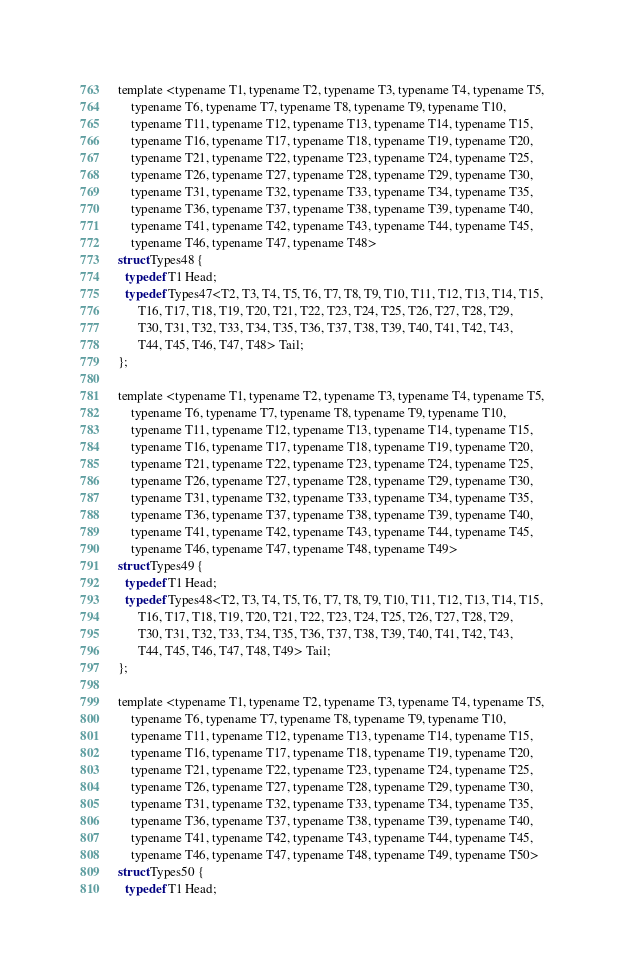<code> <loc_0><loc_0><loc_500><loc_500><_C_>template <typename T1, typename T2, typename T3, typename T4, typename T5,
    typename T6, typename T7, typename T8, typename T9, typename T10,
    typename T11, typename T12, typename T13, typename T14, typename T15,
    typename T16, typename T17, typename T18, typename T19, typename T20,
    typename T21, typename T22, typename T23, typename T24, typename T25,
    typename T26, typename T27, typename T28, typename T29, typename T30,
    typename T31, typename T32, typename T33, typename T34, typename T35,
    typename T36, typename T37, typename T38, typename T39, typename T40,
    typename T41, typename T42, typename T43, typename T44, typename T45,
    typename T46, typename T47, typename T48>
struct Types48 {
  typedef T1 Head;
  typedef Types47<T2, T3, T4, T5, T6, T7, T8, T9, T10, T11, T12, T13, T14, T15,
      T16, T17, T18, T19, T20, T21, T22, T23, T24, T25, T26, T27, T28, T29,
      T30, T31, T32, T33, T34, T35, T36, T37, T38, T39, T40, T41, T42, T43,
      T44, T45, T46, T47, T48> Tail;
};

template <typename T1, typename T2, typename T3, typename T4, typename T5,
    typename T6, typename T7, typename T8, typename T9, typename T10,
    typename T11, typename T12, typename T13, typename T14, typename T15,
    typename T16, typename T17, typename T18, typename T19, typename T20,
    typename T21, typename T22, typename T23, typename T24, typename T25,
    typename T26, typename T27, typename T28, typename T29, typename T30,
    typename T31, typename T32, typename T33, typename T34, typename T35,
    typename T36, typename T37, typename T38, typename T39, typename T40,
    typename T41, typename T42, typename T43, typename T44, typename T45,
    typename T46, typename T47, typename T48, typename T49>
struct Types49 {
  typedef T1 Head;
  typedef Types48<T2, T3, T4, T5, T6, T7, T8, T9, T10, T11, T12, T13, T14, T15,
      T16, T17, T18, T19, T20, T21, T22, T23, T24, T25, T26, T27, T28, T29,
      T30, T31, T32, T33, T34, T35, T36, T37, T38, T39, T40, T41, T42, T43,
      T44, T45, T46, T47, T48, T49> Tail;
};

template <typename T1, typename T2, typename T3, typename T4, typename T5,
    typename T6, typename T7, typename T8, typename T9, typename T10,
    typename T11, typename T12, typename T13, typename T14, typename T15,
    typename T16, typename T17, typename T18, typename T19, typename T20,
    typename T21, typename T22, typename T23, typename T24, typename T25,
    typename T26, typename T27, typename T28, typename T29, typename T30,
    typename T31, typename T32, typename T33, typename T34, typename T35,
    typename T36, typename T37, typename T38, typename T39, typename T40,
    typename T41, typename T42, typename T43, typename T44, typename T45,
    typename T46, typename T47, typename T48, typename T49, typename T50>
struct Types50 {
  typedef T1 Head;</code> 